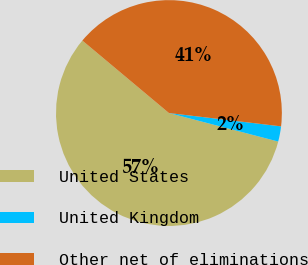Convert chart. <chart><loc_0><loc_0><loc_500><loc_500><pie_chart><fcel>United States<fcel>United Kingdom<fcel>Other net of eliminations<nl><fcel>57.03%<fcel>2.18%<fcel>40.79%<nl></chart> 